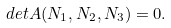Convert formula to latex. <formula><loc_0><loc_0><loc_500><loc_500>d e t A ( N _ { 1 } , N _ { 2 } , N _ { 3 } ) = 0 .</formula> 